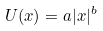<formula> <loc_0><loc_0><loc_500><loc_500>U ( x ) = a | x | ^ { b }</formula> 